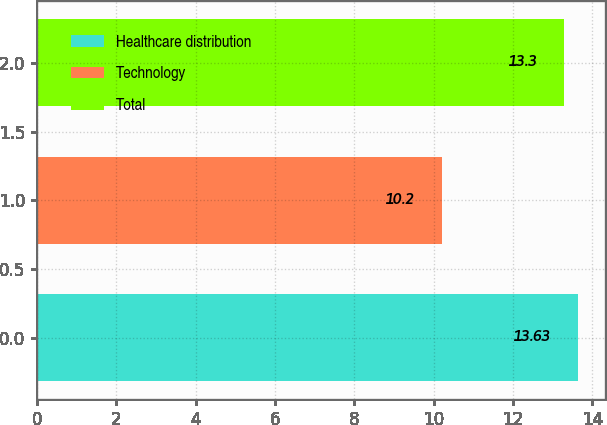Convert chart to OTSL. <chart><loc_0><loc_0><loc_500><loc_500><bar_chart><fcel>Healthcare distribution<fcel>Technology<fcel>Total<nl><fcel>13.63<fcel>10.2<fcel>13.3<nl></chart> 